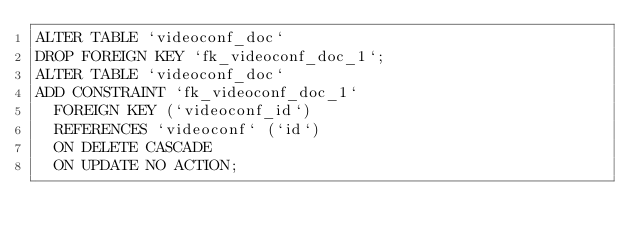<code> <loc_0><loc_0><loc_500><loc_500><_SQL_>ALTER TABLE `videoconf_doc` 
DROP FOREIGN KEY `fk_videoconf_doc_1`;
ALTER TABLE `videoconf_doc` 
ADD CONSTRAINT `fk_videoconf_doc_1`
  FOREIGN KEY (`videoconf_id`)
  REFERENCES `videoconf` (`id`)
  ON DELETE CASCADE
  ON UPDATE NO ACTION;
</code> 